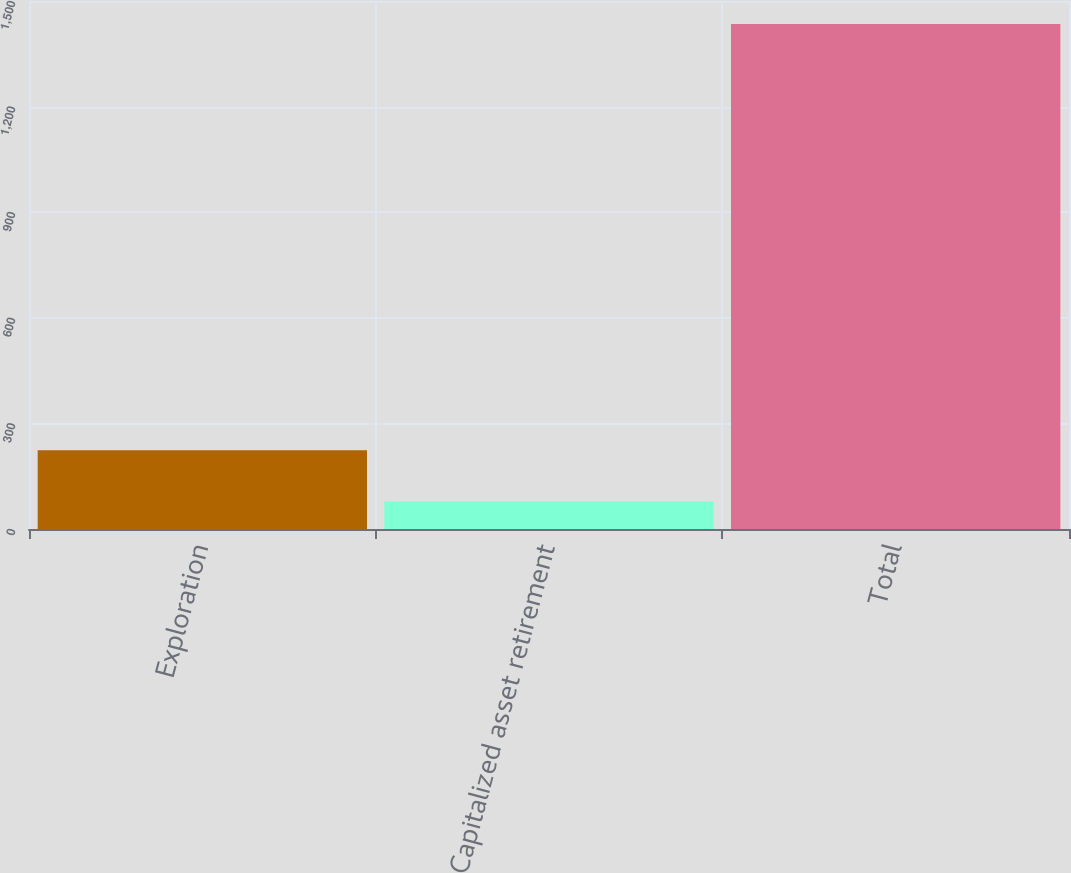Convert chart to OTSL. <chart><loc_0><loc_0><loc_500><loc_500><bar_chart><fcel>Exploration<fcel>Capitalized asset retirement<fcel>Total<nl><fcel>224<fcel>78<fcel>1435<nl></chart> 